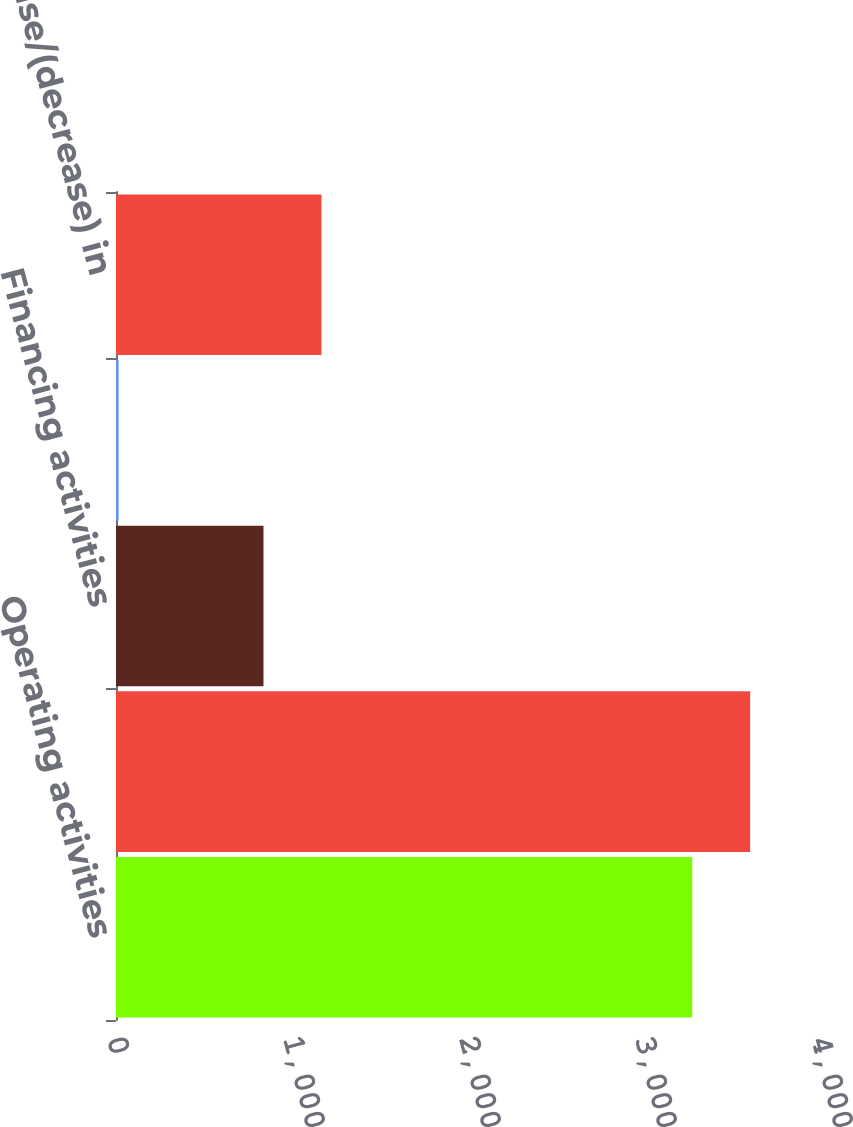Convert chart to OTSL. <chart><loc_0><loc_0><loc_500><loc_500><bar_chart><fcel>Operating activities<fcel>Investing activities<fcel>Financing activities<fcel>Effect of exchange rates on<fcel>Net increase/(decrease) in<nl><fcel>3274<fcel>3603.2<fcel>838<fcel>15<fcel>1167.2<nl></chart> 